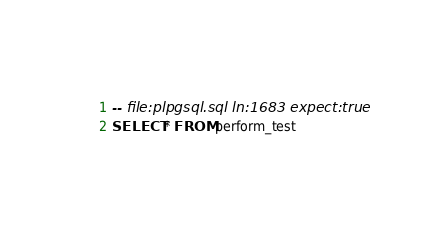Convert code to text. <code><loc_0><loc_0><loc_500><loc_500><_SQL_>-- file:plpgsql.sql ln:1683 expect:true
SELECT * FROM perform_test
</code> 